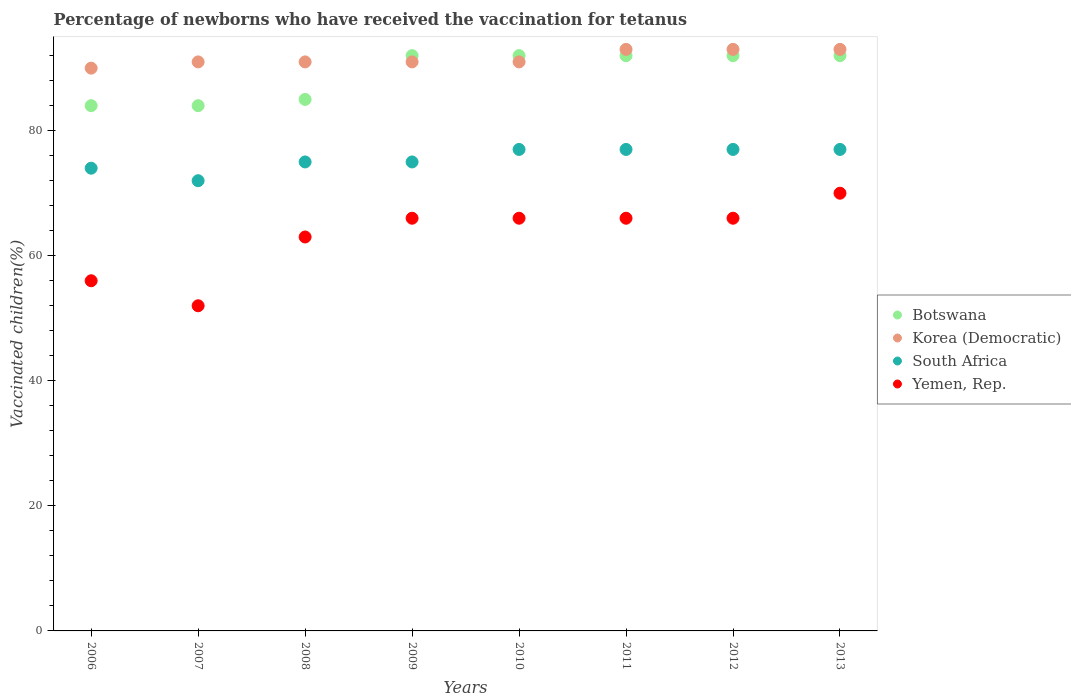How many different coloured dotlines are there?
Your answer should be compact. 4. Is the number of dotlines equal to the number of legend labels?
Give a very brief answer. Yes. Across all years, what is the maximum percentage of vaccinated children in Botswana?
Provide a short and direct response. 92. Across all years, what is the minimum percentage of vaccinated children in Yemen, Rep.?
Your response must be concise. 52. In which year was the percentage of vaccinated children in Korea (Democratic) minimum?
Make the answer very short. 2006. What is the total percentage of vaccinated children in South Africa in the graph?
Make the answer very short. 604. What is the average percentage of vaccinated children in Botswana per year?
Keep it short and to the point. 89.12. In the year 2006, what is the difference between the percentage of vaccinated children in Yemen, Rep. and percentage of vaccinated children in Korea (Democratic)?
Your answer should be very brief. -34. What is the ratio of the percentage of vaccinated children in Botswana in 2006 to that in 2013?
Provide a short and direct response. 0.91. What is the difference between the highest and the second highest percentage of vaccinated children in Yemen, Rep.?
Provide a short and direct response. 4. Is it the case that in every year, the sum of the percentage of vaccinated children in Botswana and percentage of vaccinated children in Yemen, Rep.  is greater than the sum of percentage of vaccinated children in Korea (Democratic) and percentage of vaccinated children in South Africa?
Give a very brief answer. No. Does the percentage of vaccinated children in South Africa monotonically increase over the years?
Give a very brief answer. No. How many years are there in the graph?
Give a very brief answer. 8. What is the difference between two consecutive major ticks on the Y-axis?
Offer a terse response. 20. What is the title of the graph?
Provide a short and direct response. Percentage of newborns who have received the vaccination for tetanus. Does "Panama" appear as one of the legend labels in the graph?
Keep it short and to the point. No. What is the label or title of the X-axis?
Your answer should be very brief. Years. What is the label or title of the Y-axis?
Ensure brevity in your answer.  Vaccinated children(%). What is the Vaccinated children(%) of Korea (Democratic) in 2006?
Your answer should be very brief. 90. What is the Vaccinated children(%) in South Africa in 2006?
Your answer should be compact. 74. What is the Vaccinated children(%) in Korea (Democratic) in 2007?
Your answer should be compact. 91. What is the Vaccinated children(%) of South Africa in 2007?
Ensure brevity in your answer.  72. What is the Vaccinated children(%) of Korea (Democratic) in 2008?
Keep it short and to the point. 91. What is the Vaccinated children(%) in Botswana in 2009?
Provide a succinct answer. 92. What is the Vaccinated children(%) in Korea (Democratic) in 2009?
Ensure brevity in your answer.  91. What is the Vaccinated children(%) of Yemen, Rep. in 2009?
Give a very brief answer. 66. What is the Vaccinated children(%) in Botswana in 2010?
Keep it short and to the point. 92. What is the Vaccinated children(%) in Korea (Democratic) in 2010?
Your answer should be compact. 91. What is the Vaccinated children(%) of South Africa in 2010?
Your answer should be very brief. 77. What is the Vaccinated children(%) in Botswana in 2011?
Ensure brevity in your answer.  92. What is the Vaccinated children(%) of Korea (Democratic) in 2011?
Offer a terse response. 93. What is the Vaccinated children(%) in South Africa in 2011?
Provide a succinct answer. 77. What is the Vaccinated children(%) of Botswana in 2012?
Offer a very short reply. 92. What is the Vaccinated children(%) in Korea (Democratic) in 2012?
Your answer should be very brief. 93. What is the Vaccinated children(%) in Botswana in 2013?
Your answer should be very brief. 92. What is the Vaccinated children(%) of Korea (Democratic) in 2013?
Your answer should be very brief. 93. What is the Vaccinated children(%) of South Africa in 2013?
Keep it short and to the point. 77. What is the Vaccinated children(%) of Yemen, Rep. in 2013?
Provide a succinct answer. 70. Across all years, what is the maximum Vaccinated children(%) of Botswana?
Your answer should be compact. 92. Across all years, what is the maximum Vaccinated children(%) in Korea (Democratic)?
Offer a very short reply. 93. Across all years, what is the maximum Vaccinated children(%) in South Africa?
Your response must be concise. 77. What is the total Vaccinated children(%) of Botswana in the graph?
Your answer should be compact. 713. What is the total Vaccinated children(%) of Korea (Democratic) in the graph?
Your answer should be compact. 733. What is the total Vaccinated children(%) of South Africa in the graph?
Keep it short and to the point. 604. What is the total Vaccinated children(%) in Yemen, Rep. in the graph?
Provide a short and direct response. 505. What is the difference between the Vaccinated children(%) of Botswana in 2006 and that in 2007?
Your answer should be very brief. 0. What is the difference between the Vaccinated children(%) in Korea (Democratic) in 2006 and that in 2007?
Your answer should be very brief. -1. What is the difference between the Vaccinated children(%) in South Africa in 2006 and that in 2007?
Offer a terse response. 2. What is the difference between the Vaccinated children(%) in Korea (Democratic) in 2006 and that in 2008?
Make the answer very short. -1. What is the difference between the Vaccinated children(%) in Botswana in 2006 and that in 2009?
Give a very brief answer. -8. What is the difference between the Vaccinated children(%) in Korea (Democratic) in 2006 and that in 2009?
Offer a very short reply. -1. What is the difference between the Vaccinated children(%) in Botswana in 2006 and that in 2010?
Make the answer very short. -8. What is the difference between the Vaccinated children(%) of South Africa in 2006 and that in 2010?
Provide a short and direct response. -3. What is the difference between the Vaccinated children(%) of Botswana in 2006 and that in 2011?
Your answer should be compact. -8. What is the difference between the Vaccinated children(%) in Korea (Democratic) in 2006 and that in 2011?
Provide a succinct answer. -3. What is the difference between the Vaccinated children(%) of South Africa in 2006 and that in 2011?
Your answer should be compact. -3. What is the difference between the Vaccinated children(%) in Yemen, Rep. in 2006 and that in 2011?
Give a very brief answer. -10. What is the difference between the Vaccinated children(%) of Korea (Democratic) in 2006 and that in 2012?
Make the answer very short. -3. What is the difference between the Vaccinated children(%) in Yemen, Rep. in 2006 and that in 2012?
Ensure brevity in your answer.  -10. What is the difference between the Vaccinated children(%) in South Africa in 2006 and that in 2013?
Your answer should be very brief. -3. What is the difference between the Vaccinated children(%) in Yemen, Rep. in 2006 and that in 2013?
Offer a terse response. -14. What is the difference between the Vaccinated children(%) in Botswana in 2007 and that in 2008?
Your answer should be compact. -1. What is the difference between the Vaccinated children(%) in South Africa in 2007 and that in 2008?
Give a very brief answer. -3. What is the difference between the Vaccinated children(%) of Botswana in 2007 and that in 2009?
Make the answer very short. -8. What is the difference between the Vaccinated children(%) of Botswana in 2007 and that in 2011?
Offer a very short reply. -8. What is the difference between the Vaccinated children(%) of Korea (Democratic) in 2007 and that in 2011?
Provide a short and direct response. -2. What is the difference between the Vaccinated children(%) of Yemen, Rep. in 2007 and that in 2011?
Give a very brief answer. -14. What is the difference between the Vaccinated children(%) of Botswana in 2007 and that in 2012?
Ensure brevity in your answer.  -8. What is the difference between the Vaccinated children(%) of Yemen, Rep. in 2007 and that in 2012?
Provide a short and direct response. -14. What is the difference between the Vaccinated children(%) in Botswana in 2007 and that in 2013?
Ensure brevity in your answer.  -8. What is the difference between the Vaccinated children(%) of Korea (Democratic) in 2007 and that in 2013?
Provide a succinct answer. -2. What is the difference between the Vaccinated children(%) in South Africa in 2007 and that in 2013?
Provide a succinct answer. -5. What is the difference between the Vaccinated children(%) in South Africa in 2008 and that in 2009?
Offer a very short reply. 0. What is the difference between the Vaccinated children(%) of Yemen, Rep. in 2008 and that in 2009?
Your answer should be compact. -3. What is the difference between the Vaccinated children(%) of Botswana in 2008 and that in 2010?
Your answer should be very brief. -7. What is the difference between the Vaccinated children(%) of Korea (Democratic) in 2008 and that in 2010?
Keep it short and to the point. 0. What is the difference between the Vaccinated children(%) of South Africa in 2008 and that in 2010?
Give a very brief answer. -2. What is the difference between the Vaccinated children(%) in Yemen, Rep. in 2008 and that in 2010?
Your answer should be compact. -3. What is the difference between the Vaccinated children(%) of Botswana in 2008 and that in 2011?
Offer a very short reply. -7. What is the difference between the Vaccinated children(%) of South Africa in 2008 and that in 2011?
Ensure brevity in your answer.  -2. What is the difference between the Vaccinated children(%) of Yemen, Rep. in 2008 and that in 2011?
Your response must be concise. -3. What is the difference between the Vaccinated children(%) in Botswana in 2008 and that in 2012?
Make the answer very short. -7. What is the difference between the Vaccinated children(%) of Korea (Democratic) in 2008 and that in 2012?
Provide a short and direct response. -2. What is the difference between the Vaccinated children(%) in South Africa in 2008 and that in 2012?
Offer a very short reply. -2. What is the difference between the Vaccinated children(%) of Yemen, Rep. in 2008 and that in 2012?
Offer a very short reply. -3. What is the difference between the Vaccinated children(%) of South Africa in 2008 and that in 2013?
Offer a very short reply. -2. What is the difference between the Vaccinated children(%) of Yemen, Rep. in 2008 and that in 2013?
Provide a succinct answer. -7. What is the difference between the Vaccinated children(%) of Botswana in 2009 and that in 2010?
Your answer should be compact. 0. What is the difference between the Vaccinated children(%) of Yemen, Rep. in 2009 and that in 2010?
Offer a terse response. 0. What is the difference between the Vaccinated children(%) of Botswana in 2009 and that in 2011?
Your answer should be very brief. 0. What is the difference between the Vaccinated children(%) in Korea (Democratic) in 2009 and that in 2011?
Ensure brevity in your answer.  -2. What is the difference between the Vaccinated children(%) in Botswana in 2009 and that in 2012?
Your response must be concise. 0. What is the difference between the Vaccinated children(%) of South Africa in 2009 and that in 2012?
Make the answer very short. -2. What is the difference between the Vaccinated children(%) of Yemen, Rep. in 2009 and that in 2012?
Your answer should be compact. 0. What is the difference between the Vaccinated children(%) in Botswana in 2009 and that in 2013?
Your answer should be compact. 0. What is the difference between the Vaccinated children(%) in Korea (Democratic) in 2010 and that in 2011?
Offer a terse response. -2. What is the difference between the Vaccinated children(%) of Yemen, Rep. in 2010 and that in 2011?
Keep it short and to the point. 0. What is the difference between the Vaccinated children(%) of Botswana in 2010 and that in 2012?
Your answer should be very brief. 0. What is the difference between the Vaccinated children(%) of Yemen, Rep. in 2010 and that in 2012?
Provide a succinct answer. 0. What is the difference between the Vaccinated children(%) in Botswana in 2010 and that in 2013?
Keep it short and to the point. 0. What is the difference between the Vaccinated children(%) of South Africa in 2010 and that in 2013?
Provide a short and direct response. 0. What is the difference between the Vaccinated children(%) of Yemen, Rep. in 2010 and that in 2013?
Offer a terse response. -4. What is the difference between the Vaccinated children(%) in Botswana in 2011 and that in 2012?
Make the answer very short. 0. What is the difference between the Vaccinated children(%) in Yemen, Rep. in 2011 and that in 2012?
Your answer should be compact. 0. What is the difference between the Vaccinated children(%) of South Africa in 2011 and that in 2013?
Provide a succinct answer. 0. What is the difference between the Vaccinated children(%) in Yemen, Rep. in 2011 and that in 2013?
Provide a short and direct response. -4. What is the difference between the Vaccinated children(%) in Botswana in 2012 and that in 2013?
Your answer should be compact. 0. What is the difference between the Vaccinated children(%) of South Africa in 2012 and that in 2013?
Offer a very short reply. 0. What is the difference between the Vaccinated children(%) in Botswana in 2006 and the Vaccinated children(%) in South Africa in 2007?
Your answer should be compact. 12. What is the difference between the Vaccinated children(%) in Botswana in 2006 and the Vaccinated children(%) in Yemen, Rep. in 2007?
Make the answer very short. 32. What is the difference between the Vaccinated children(%) in Korea (Democratic) in 2006 and the Vaccinated children(%) in South Africa in 2007?
Keep it short and to the point. 18. What is the difference between the Vaccinated children(%) in Botswana in 2006 and the Vaccinated children(%) in Korea (Democratic) in 2008?
Provide a succinct answer. -7. What is the difference between the Vaccinated children(%) of Botswana in 2006 and the Vaccinated children(%) of Yemen, Rep. in 2008?
Your answer should be very brief. 21. What is the difference between the Vaccinated children(%) in Korea (Democratic) in 2006 and the Vaccinated children(%) in Yemen, Rep. in 2008?
Your answer should be compact. 27. What is the difference between the Vaccinated children(%) of South Africa in 2006 and the Vaccinated children(%) of Yemen, Rep. in 2008?
Your response must be concise. 11. What is the difference between the Vaccinated children(%) in Botswana in 2006 and the Vaccinated children(%) in Yemen, Rep. in 2009?
Your response must be concise. 18. What is the difference between the Vaccinated children(%) of Korea (Democratic) in 2006 and the Vaccinated children(%) of Yemen, Rep. in 2009?
Your answer should be compact. 24. What is the difference between the Vaccinated children(%) of South Africa in 2006 and the Vaccinated children(%) of Yemen, Rep. in 2009?
Provide a short and direct response. 8. What is the difference between the Vaccinated children(%) in Botswana in 2006 and the Vaccinated children(%) in Korea (Democratic) in 2010?
Your answer should be compact. -7. What is the difference between the Vaccinated children(%) in Botswana in 2006 and the Vaccinated children(%) in South Africa in 2010?
Your answer should be very brief. 7. What is the difference between the Vaccinated children(%) of Korea (Democratic) in 2006 and the Vaccinated children(%) of Yemen, Rep. in 2010?
Ensure brevity in your answer.  24. What is the difference between the Vaccinated children(%) of South Africa in 2006 and the Vaccinated children(%) of Yemen, Rep. in 2010?
Offer a very short reply. 8. What is the difference between the Vaccinated children(%) in Botswana in 2006 and the Vaccinated children(%) in Korea (Democratic) in 2011?
Provide a succinct answer. -9. What is the difference between the Vaccinated children(%) of Korea (Democratic) in 2006 and the Vaccinated children(%) of South Africa in 2011?
Your response must be concise. 13. What is the difference between the Vaccinated children(%) in South Africa in 2006 and the Vaccinated children(%) in Yemen, Rep. in 2011?
Your answer should be very brief. 8. What is the difference between the Vaccinated children(%) of Botswana in 2006 and the Vaccinated children(%) of Korea (Democratic) in 2012?
Your answer should be very brief. -9. What is the difference between the Vaccinated children(%) of Botswana in 2006 and the Vaccinated children(%) of South Africa in 2012?
Provide a succinct answer. 7. What is the difference between the Vaccinated children(%) in Botswana in 2006 and the Vaccinated children(%) in Yemen, Rep. in 2012?
Offer a very short reply. 18. What is the difference between the Vaccinated children(%) in Korea (Democratic) in 2006 and the Vaccinated children(%) in South Africa in 2012?
Offer a very short reply. 13. What is the difference between the Vaccinated children(%) in Korea (Democratic) in 2006 and the Vaccinated children(%) in Yemen, Rep. in 2012?
Your response must be concise. 24. What is the difference between the Vaccinated children(%) in Botswana in 2006 and the Vaccinated children(%) in Yemen, Rep. in 2013?
Your response must be concise. 14. What is the difference between the Vaccinated children(%) of Korea (Democratic) in 2006 and the Vaccinated children(%) of South Africa in 2013?
Ensure brevity in your answer.  13. What is the difference between the Vaccinated children(%) of Korea (Democratic) in 2006 and the Vaccinated children(%) of Yemen, Rep. in 2013?
Keep it short and to the point. 20. What is the difference between the Vaccinated children(%) of South Africa in 2006 and the Vaccinated children(%) of Yemen, Rep. in 2013?
Offer a very short reply. 4. What is the difference between the Vaccinated children(%) in Botswana in 2007 and the Vaccinated children(%) in Korea (Democratic) in 2008?
Provide a succinct answer. -7. What is the difference between the Vaccinated children(%) in Botswana in 2007 and the Vaccinated children(%) in South Africa in 2008?
Make the answer very short. 9. What is the difference between the Vaccinated children(%) of Korea (Democratic) in 2007 and the Vaccinated children(%) of South Africa in 2008?
Make the answer very short. 16. What is the difference between the Vaccinated children(%) of Botswana in 2007 and the Vaccinated children(%) of Korea (Democratic) in 2009?
Provide a succinct answer. -7. What is the difference between the Vaccinated children(%) in Botswana in 2007 and the Vaccinated children(%) in South Africa in 2009?
Provide a short and direct response. 9. What is the difference between the Vaccinated children(%) in Botswana in 2007 and the Vaccinated children(%) in Yemen, Rep. in 2009?
Your answer should be very brief. 18. What is the difference between the Vaccinated children(%) of Korea (Democratic) in 2007 and the Vaccinated children(%) of South Africa in 2009?
Offer a very short reply. 16. What is the difference between the Vaccinated children(%) in South Africa in 2007 and the Vaccinated children(%) in Yemen, Rep. in 2009?
Your response must be concise. 6. What is the difference between the Vaccinated children(%) of Botswana in 2007 and the Vaccinated children(%) of Korea (Democratic) in 2010?
Ensure brevity in your answer.  -7. What is the difference between the Vaccinated children(%) in Botswana in 2007 and the Vaccinated children(%) in Yemen, Rep. in 2010?
Keep it short and to the point. 18. What is the difference between the Vaccinated children(%) of Korea (Democratic) in 2007 and the Vaccinated children(%) of South Africa in 2010?
Make the answer very short. 14. What is the difference between the Vaccinated children(%) of Botswana in 2007 and the Vaccinated children(%) of Korea (Democratic) in 2011?
Offer a terse response. -9. What is the difference between the Vaccinated children(%) of Botswana in 2007 and the Vaccinated children(%) of Yemen, Rep. in 2011?
Keep it short and to the point. 18. What is the difference between the Vaccinated children(%) of Korea (Democratic) in 2007 and the Vaccinated children(%) of Yemen, Rep. in 2011?
Make the answer very short. 25. What is the difference between the Vaccinated children(%) in Botswana in 2007 and the Vaccinated children(%) in Korea (Democratic) in 2012?
Your answer should be compact. -9. What is the difference between the Vaccinated children(%) in Botswana in 2007 and the Vaccinated children(%) in South Africa in 2012?
Ensure brevity in your answer.  7. What is the difference between the Vaccinated children(%) of Botswana in 2007 and the Vaccinated children(%) of Yemen, Rep. in 2012?
Your answer should be compact. 18. What is the difference between the Vaccinated children(%) in Korea (Democratic) in 2007 and the Vaccinated children(%) in South Africa in 2013?
Offer a very short reply. 14. What is the difference between the Vaccinated children(%) in Botswana in 2008 and the Vaccinated children(%) in South Africa in 2009?
Give a very brief answer. 10. What is the difference between the Vaccinated children(%) in South Africa in 2008 and the Vaccinated children(%) in Yemen, Rep. in 2009?
Provide a succinct answer. 9. What is the difference between the Vaccinated children(%) in Botswana in 2008 and the Vaccinated children(%) in South Africa in 2010?
Make the answer very short. 8. What is the difference between the Vaccinated children(%) of Korea (Democratic) in 2008 and the Vaccinated children(%) of South Africa in 2010?
Your response must be concise. 14. What is the difference between the Vaccinated children(%) in Korea (Democratic) in 2008 and the Vaccinated children(%) in Yemen, Rep. in 2010?
Offer a very short reply. 25. What is the difference between the Vaccinated children(%) in South Africa in 2008 and the Vaccinated children(%) in Yemen, Rep. in 2010?
Offer a terse response. 9. What is the difference between the Vaccinated children(%) of Botswana in 2008 and the Vaccinated children(%) of Korea (Democratic) in 2011?
Ensure brevity in your answer.  -8. What is the difference between the Vaccinated children(%) in Botswana in 2008 and the Vaccinated children(%) in Yemen, Rep. in 2011?
Make the answer very short. 19. What is the difference between the Vaccinated children(%) of Korea (Democratic) in 2008 and the Vaccinated children(%) of South Africa in 2011?
Keep it short and to the point. 14. What is the difference between the Vaccinated children(%) of South Africa in 2008 and the Vaccinated children(%) of Yemen, Rep. in 2011?
Your answer should be very brief. 9. What is the difference between the Vaccinated children(%) of Botswana in 2008 and the Vaccinated children(%) of South Africa in 2012?
Keep it short and to the point. 8. What is the difference between the Vaccinated children(%) in Botswana in 2008 and the Vaccinated children(%) in South Africa in 2013?
Make the answer very short. 8. What is the difference between the Vaccinated children(%) in Botswana in 2008 and the Vaccinated children(%) in Yemen, Rep. in 2013?
Your answer should be compact. 15. What is the difference between the Vaccinated children(%) in Korea (Democratic) in 2008 and the Vaccinated children(%) in South Africa in 2013?
Your response must be concise. 14. What is the difference between the Vaccinated children(%) in Korea (Democratic) in 2008 and the Vaccinated children(%) in Yemen, Rep. in 2013?
Your response must be concise. 21. What is the difference between the Vaccinated children(%) of Korea (Democratic) in 2009 and the Vaccinated children(%) of South Africa in 2010?
Your response must be concise. 14. What is the difference between the Vaccinated children(%) in Korea (Democratic) in 2009 and the Vaccinated children(%) in Yemen, Rep. in 2010?
Make the answer very short. 25. What is the difference between the Vaccinated children(%) of Botswana in 2009 and the Vaccinated children(%) of Yemen, Rep. in 2011?
Make the answer very short. 26. What is the difference between the Vaccinated children(%) in Korea (Democratic) in 2009 and the Vaccinated children(%) in South Africa in 2011?
Offer a very short reply. 14. What is the difference between the Vaccinated children(%) in South Africa in 2009 and the Vaccinated children(%) in Yemen, Rep. in 2011?
Your answer should be compact. 9. What is the difference between the Vaccinated children(%) in Korea (Democratic) in 2009 and the Vaccinated children(%) in South Africa in 2012?
Your answer should be very brief. 14. What is the difference between the Vaccinated children(%) in South Africa in 2009 and the Vaccinated children(%) in Yemen, Rep. in 2012?
Your response must be concise. 9. What is the difference between the Vaccinated children(%) in Botswana in 2009 and the Vaccinated children(%) in Korea (Democratic) in 2013?
Offer a very short reply. -1. What is the difference between the Vaccinated children(%) in Korea (Democratic) in 2009 and the Vaccinated children(%) in South Africa in 2013?
Offer a terse response. 14. What is the difference between the Vaccinated children(%) of South Africa in 2009 and the Vaccinated children(%) of Yemen, Rep. in 2013?
Offer a terse response. 5. What is the difference between the Vaccinated children(%) in Korea (Democratic) in 2010 and the Vaccinated children(%) in South Africa in 2011?
Offer a terse response. 14. What is the difference between the Vaccinated children(%) in South Africa in 2010 and the Vaccinated children(%) in Yemen, Rep. in 2011?
Make the answer very short. 11. What is the difference between the Vaccinated children(%) in Botswana in 2010 and the Vaccinated children(%) in Yemen, Rep. in 2012?
Give a very brief answer. 26. What is the difference between the Vaccinated children(%) in Korea (Democratic) in 2010 and the Vaccinated children(%) in Yemen, Rep. in 2012?
Offer a terse response. 25. What is the difference between the Vaccinated children(%) in Botswana in 2010 and the Vaccinated children(%) in South Africa in 2013?
Give a very brief answer. 15. What is the difference between the Vaccinated children(%) of Botswana in 2010 and the Vaccinated children(%) of Yemen, Rep. in 2013?
Provide a short and direct response. 22. What is the difference between the Vaccinated children(%) of Korea (Democratic) in 2010 and the Vaccinated children(%) of South Africa in 2013?
Provide a succinct answer. 14. What is the difference between the Vaccinated children(%) in Korea (Democratic) in 2010 and the Vaccinated children(%) in Yemen, Rep. in 2013?
Your answer should be very brief. 21. What is the difference between the Vaccinated children(%) of Botswana in 2011 and the Vaccinated children(%) of Korea (Democratic) in 2012?
Provide a succinct answer. -1. What is the difference between the Vaccinated children(%) of Botswana in 2011 and the Vaccinated children(%) of South Africa in 2012?
Provide a short and direct response. 15. What is the difference between the Vaccinated children(%) of Botswana in 2011 and the Vaccinated children(%) of Yemen, Rep. in 2012?
Your answer should be very brief. 26. What is the difference between the Vaccinated children(%) of Korea (Democratic) in 2011 and the Vaccinated children(%) of South Africa in 2012?
Give a very brief answer. 16. What is the difference between the Vaccinated children(%) of Korea (Democratic) in 2011 and the Vaccinated children(%) of Yemen, Rep. in 2012?
Your answer should be compact. 27. What is the difference between the Vaccinated children(%) of Botswana in 2011 and the Vaccinated children(%) of Yemen, Rep. in 2013?
Keep it short and to the point. 22. What is the difference between the Vaccinated children(%) in South Africa in 2011 and the Vaccinated children(%) in Yemen, Rep. in 2013?
Your response must be concise. 7. What is the difference between the Vaccinated children(%) of Botswana in 2012 and the Vaccinated children(%) of Korea (Democratic) in 2013?
Provide a short and direct response. -1. What is the difference between the Vaccinated children(%) in Korea (Democratic) in 2012 and the Vaccinated children(%) in South Africa in 2013?
Make the answer very short. 16. What is the average Vaccinated children(%) in Botswana per year?
Provide a short and direct response. 89.12. What is the average Vaccinated children(%) in Korea (Democratic) per year?
Offer a very short reply. 91.62. What is the average Vaccinated children(%) in South Africa per year?
Offer a terse response. 75.5. What is the average Vaccinated children(%) in Yemen, Rep. per year?
Offer a terse response. 63.12. In the year 2006, what is the difference between the Vaccinated children(%) of Botswana and Vaccinated children(%) of Korea (Democratic)?
Give a very brief answer. -6. In the year 2006, what is the difference between the Vaccinated children(%) in Botswana and Vaccinated children(%) in South Africa?
Offer a terse response. 10. In the year 2006, what is the difference between the Vaccinated children(%) of Botswana and Vaccinated children(%) of Yemen, Rep.?
Your response must be concise. 28. In the year 2006, what is the difference between the Vaccinated children(%) of Korea (Democratic) and Vaccinated children(%) of South Africa?
Ensure brevity in your answer.  16. In the year 2007, what is the difference between the Vaccinated children(%) of Botswana and Vaccinated children(%) of Korea (Democratic)?
Make the answer very short. -7. In the year 2008, what is the difference between the Vaccinated children(%) of Botswana and Vaccinated children(%) of Yemen, Rep.?
Keep it short and to the point. 22. In the year 2008, what is the difference between the Vaccinated children(%) in Korea (Democratic) and Vaccinated children(%) in South Africa?
Provide a short and direct response. 16. In the year 2009, what is the difference between the Vaccinated children(%) of Korea (Democratic) and Vaccinated children(%) of South Africa?
Your answer should be compact. 16. In the year 2009, what is the difference between the Vaccinated children(%) of South Africa and Vaccinated children(%) of Yemen, Rep.?
Provide a short and direct response. 9. In the year 2010, what is the difference between the Vaccinated children(%) in Korea (Democratic) and Vaccinated children(%) in South Africa?
Your answer should be compact. 14. In the year 2010, what is the difference between the Vaccinated children(%) in Korea (Democratic) and Vaccinated children(%) in Yemen, Rep.?
Your answer should be compact. 25. In the year 2011, what is the difference between the Vaccinated children(%) in Botswana and Vaccinated children(%) in Korea (Democratic)?
Offer a very short reply. -1. In the year 2011, what is the difference between the Vaccinated children(%) of Botswana and Vaccinated children(%) of South Africa?
Offer a very short reply. 15. In the year 2011, what is the difference between the Vaccinated children(%) of Botswana and Vaccinated children(%) of Yemen, Rep.?
Make the answer very short. 26. In the year 2011, what is the difference between the Vaccinated children(%) of Korea (Democratic) and Vaccinated children(%) of Yemen, Rep.?
Give a very brief answer. 27. In the year 2012, what is the difference between the Vaccinated children(%) in Botswana and Vaccinated children(%) in South Africa?
Make the answer very short. 15. In the year 2012, what is the difference between the Vaccinated children(%) in Botswana and Vaccinated children(%) in Yemen, Rep.?
Your response must be concise. 26. In the year 2012, what is the difference between the Vaccinated children(%) in Korea (Democratic) and Vaccinated children(%) in South Africa?
Your response must be concise. 16. In the year 2012, what is the difference between the Vaccinated children(%) of Korea (Democratic) and Vaccinated children(%) of Yemen, Rep.?
Give a very brief answer. 27. In the year 2012, what is the difference between the Vaccinated children(%) of South Africa and Vaccinated children(%) of Yemen, Rep.?
Offer a terse response. 11. In the year 2013, what is the difference between the Vaccinated children(%) of Korea (Democratic) and Vaccinated children(%) of South Africa?
Offer a terse response. 16. In the year 2013, what is the difference between the Vaccinated children(%) in South Africa and Vaccinated children(%) in Yemen, Rep.?
Your answer should be very brief. 7. What is the ratio of the Vaccinated children(%) of Botswana in 2006 to that in 2007?
Keep it short and to the point. 1. What is the ratio of the Vaccinated children(%) of South Africa in 2006 to that in 2007?
Keep it short and to the point. 1.03. What is the ratio of the Vaccinated children(%) in Korea (Democratic) in 2006 to that in 2008?
Ensure brevity in your answer.  0.99. What is the ratio of the Vaccinated children(%) in South Africa in 2006 to that in 2008?
Ensure brevity in your answer.  0.99. What is the ratio of the Vaccinated children(%) of Yemen, Rep. in 2006 to that in 2008?
Your response must be concise. 0.89. What is the ratio of the Vaccinated children(%) in South Africa in 2006 to that in 2009?
Offer a very short reply. 0.99. What is the ratio of the Vaccinated children(%) in Yemen, Rep. in 2006 to that in 2009?
Give a very brief answer. 0.85. What is the ratio of the Vaccinated children(%) in Korea (Democratic) in 2006 to that in 2010?
Your answer should be very brief. 0.99. What is the ratio of the Vaccinated children(%) of Yemen, Rep. in 2006 to that in 2010?
Make the answer very short. 0.85. What is the ratio of the Vaccinated children(%) of Yemen, Rep. in 2006 to that in 2011?
Keep it short and to the point. 0.85. What is the ratio of the Vaccinated children(%) of Korea (Democratic) in 2006 to that in 2012?
Keep it short and to the point. 0.97. What is the ratio of the Vaccinated children(%) of South Africa in 2006 to that in 2012?
Provide a succinct answer. 0.96. What is the ratio of the Vaccinated children(%) of Yemen, Rep. in 2006 to that in 2012?
Offer a very short reply. 0.85. What is the ratio of the Vaccinated children(%) in Botswana in 2006 to that in 2013?
Offer a very short reply. 0.91. What is the ratio of the Vaccinated children(%) in Yemen, Rep. in 2007 to that in 2008?
Provide a short and direct response. 0.83. What is the ratio of the Vaccinated children(%) of Botswana in 2007 to that in 2009?
Ensure brevity in your answer.  0.91. What is the ratio of the Vaccinated children(%) in South Africa in 2007 to that in 2009?
Your answer should be very brief. 0.96. What is the ratio of the Vaccinated children(%) in Yemen, Rep. in 2007 to that in 2009?
Make the answer very short. 0.79. What is the ratio of the Vaccinated children(%) in Korea (Democratic) in 2007 to that in 2010?
Make the answer very short. 1. What is the ratio of the Vaccinated children(%) of South Africa in 2007 to that in 2010?
Provide a short and direct response. 0.94. What is the ratio of the Vaccinated children(%) of Yemen, Rep. in 2007 to that in 2010?
Give a very brief answer. 0.79. What is the ratio of the Vaccinated children(%) in Korea (Democratic) in 2007 to that in 2011?
Provide a succinct answer. 0.98. What is the ratio of the Vaccinated children(%) of South Africa in 2007 to that in 2011?
Provide a succinct answer. 0.94. What is the ratio of the Vaccinated children(%) of Yemen, Rep. in 2007 to that in 2011?
Your response must be concise. 0.79. What is the ratio of the Vaccinated children(%) of Botswana in 2007 to that in 2012?
Your answer should be very brief. 0.91. What is the ratio of the Vaccinated children(%) of Korea (Democratic) in 2007 to that in 2012?
Your answer should be very brief. 0.98. What is the ratio of the Vaccinated children(%) of South Africa in 2007 to that in 2012?
Ensure brevity in your answer.  0.94. What is the ratio of the Vaccinated children(%) of Yemen, Rep. in 2007 to that in 2012?
Provide a short and direct response. 0.79. What is the ratio of the Vaccinated children(%) of Botswana in 2007 to that in 2013?
Your answer should be very brief. 0.91. What is the ratio of the Vaccinated children(%) of Korea (Democratic) in 2007 to that in 2013?
Make the answer very short. 0.98. What is the ratio of the Vaccinated children(%) of South Africa in 2007 to that in 2013?
Offer a very short reply. 0.94. What is the ratio of the Vaccinated children(%) in Yemen, Rep. in 2007 to that in 2013?
Your answer should be very brief. 0.74. What is the ratio of the Vaccinated children(%) of Botswana in 2008 to that in 2009?
Offer a very short reply. 0.92. What is the ratio of the Vaccinated children(%) of South Africa in 2008 to that in 2009?
Your answer should be compact. 1. What is the ratio of the Vaccinated children(%) of Yemen, Rep. in 2008 to that in 2009?
Your answer should be compact. 0.95. What is the ratio of the Vaccinated children(%) of Botswana in 2008 to that in 2010?
Give a very brief answer. 0.92. What is the ratio of the Vaccinated children(%) in South Africa in 2008 to that in 2010?
Your answer should be very brief. 0.97. What is the ratio of the Vaccinated children(%) in Yemen, Rep. in 2008 to that in 2010?
Offer a terse response. 0.95. What is the ratio of the Vaccinated children(%) of Botswana in 2008 to that in 2011?
Provide a short and direct response. 0.92. What is the ratio of the Vaccinated children(%) of Korea (Democratic) in 2008 to that in 2011?
Give a very brief answer. 0.98. What is the ratio of the Vaccinated children(%) in South Africa in 2008 to that in 2011?
Give a very brief answer. 0.97. What is the ratio of the Vaccinated children(%) in Yemen, Rep. in 2008 to that in 2011?
Provide a succinct answer. 0.95. What is the ratio of the Vaccinated children(%) in Botswana in 2008 to that in 2012?
Make the answer very short. 0.92. What is the ratio of the Vaccinated children(%) of Korea (Democratic) in 2008 to that in 2012?
Ensure brevity in your answer.  0.98. What is the ratio of the Vaccinated children(%) in South Africa in 2008 to that in 2012?
Provide a succinct answer. 0.97. What is the ratio of the Vaccinated children(%) in Yemen, Rep. in 2008 to that in 2012?
Your answer should be compact. 0.95. What is the ratio of the Vaccinated children(%) in Botswana in 2008 to that in 2013?
Your answer should be very brief. 0.92. What is the ratio of the Vaccinated children(%) of Korea (Democratic) in 2008 to that in 2013?
Offer a very short reply. 0.98. What is the ratio of the Vaccinated children(%) of Botswana in 2009 to that in 2010?
Offer a terse response. 1. What is the ratio of the Vaccinated children(%) of South Africa in 2009 to that in 2010?
Make the answer very short. 0.97. What is the ratio of the Vaccinated children(%) in Botswana in 2009 to that in 2011?
Provide a short and direct response. 1. What is the ratio of the Vaccinated children(%) of Korea (Democratic) in 2009 to that in 2011?
Your response must be concise. 0.98. What is the ratio of the Vaccinated children(%) of Botswana in 2009 to that in 2012?
Offer a terse response. 1. What is the ratio of the Vaccinated children(%) of Korea (Democratic) in 2009 to that in 2012?
Keep it short and to the point. 0.98. What is the ratio of the Vaccinated children(%) in Korea (Democratic) in 2009 to that in 2013?
Ensure brevity in your answer.  0.98. What is the ratio of the Vaccinated children(%) in Yemen, Rep. in 2009 to that in 2013?
Your answer should be compact. 0.94. What is the ratio of the Vaccinated children(%) in Korea (Democratic) in 2010 to that in 2011?
Your answer should be compact. 0.98. What is the ratio of the Vaccinated children(%) in Korea (Democratic) in 2010 to that in 2012?
Provide a short and direct response. 0.98. What is the ratio of the Vaccinated children(%) of South Africa in 2010 to that in 2012?
Provide a succinct answer. 1. What is the ratio of the Vaccinated children(%) of Yemen, Rep. in 2010 to that in 2012?
Provide a short and direct response. 1. What is the ratio of the Vaccinated children(%) of Korea (Democratic) in 2010 to that in 2013?
Offer a terse response. 0.98. What is the ratio of the Vaccinated children(%) of South Africa in 2010 to that in 2013?
Ensure brevity in your answer.  1. What is the ratio of the Vaccinated children(%) of Yemen, Rep. in 2010 to that in 2013?
Your answer should be compact. 0.94. What is the ratio of the Vaccinated children(%) in South Africa in 2011 to that in 2012?
Make the answer very short. 1. What is the ratio of the Vaccinated children(%) in Korea (Democratic) in 2011 to that in 2013?
Offer a very short reply. 1. What is the ratio of the Vaccinated children(%) of Yemen, Rep. in 2011 to that in 2013?
Offer a terse response. 0.94. What is the ratio of the Vaccinated children(%) of Yemen, Rep. in 2012 to that in 2013?
Provide a short and direct response. 0.94. What is the difference between the highest and the second highest Vaccinated children(%) of South Africa?
Your answer should be very brief. 0. What is the difference between the highest and the lowest Vaccinated children(%) of Botswana?
Give a very brief answer. 8. What is the difference between the highest and the lowest Vaccinated children(%) of South Africa?
Ensure brevity in your answer.  5. 